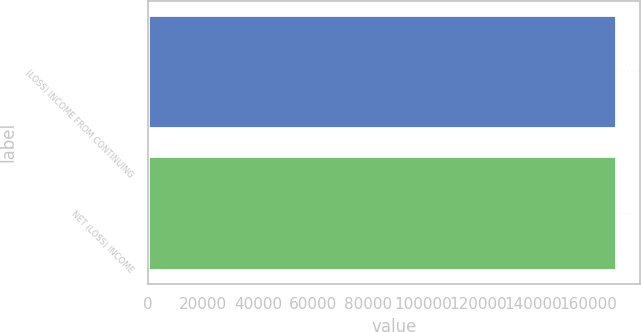Convert chart to OTSL. <chart><loc_0><loc_0><loc_500><loc_500><bar_chart><fcel>(LOSS) INCOME FROM CONTINUING<fcel>NET (LOSS) INCOME<nl><fcel>170126<fcel>170126<nl></chart> 